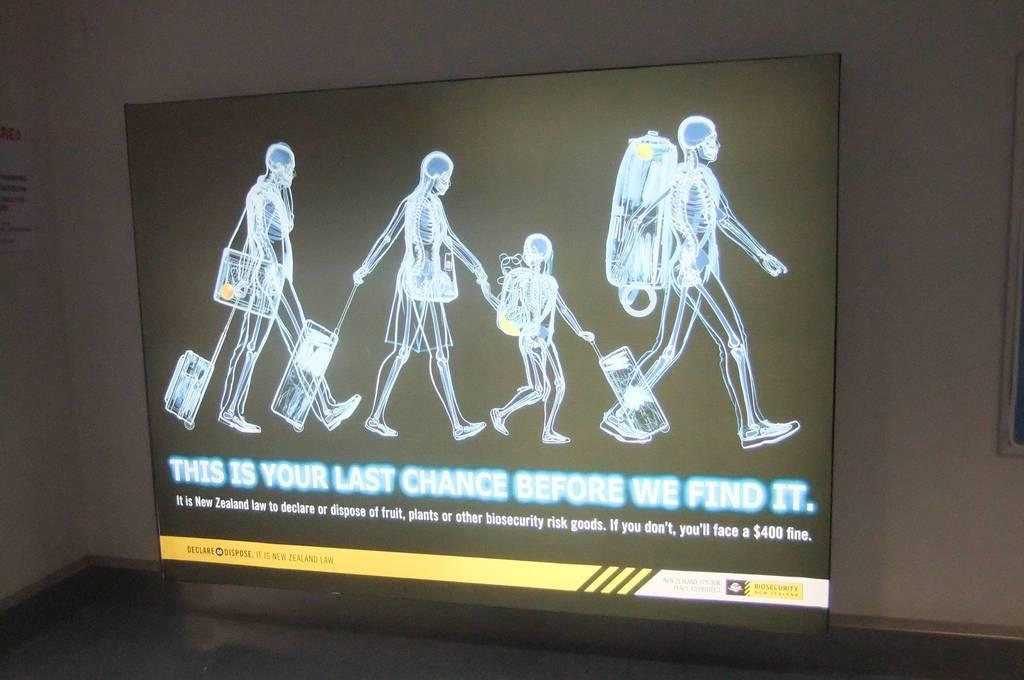What is the main object in the center of the image? There is a screen in the center of the image. What can be seen on the screen? There are images and text written on the screen. What type of canvas is being used to create the images on the screen? There is no canvas present in the image, as the images are displayed on a screen. Is there a jail visible in the image? No, there is no jail present in the image. 